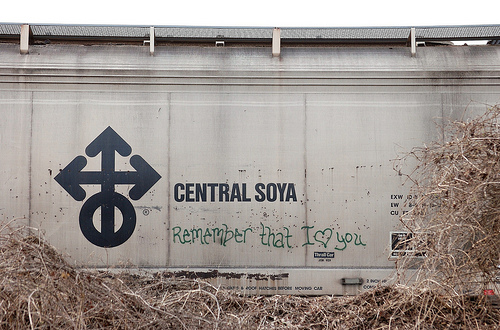<image>
Is the heart above the ground? Yes. The heart is positioned above the ground in the vertical space, higher up in the scene. 